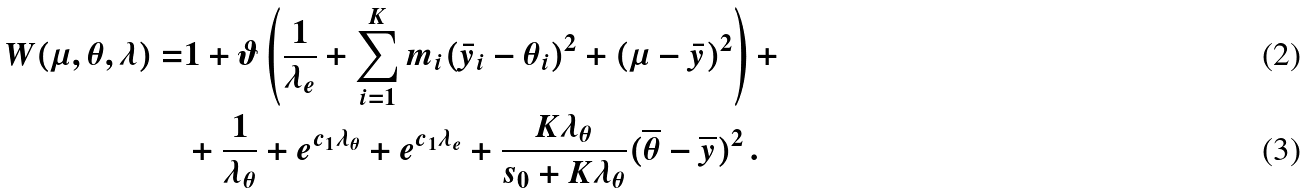<formula> <loc_0><loc_0><loc_500><loc_500>W ( \mu , \theta , \lambda ) = & 1 + \vartheta \left ( \frac { 1 } { \lambda _ { e } } + \sum _ { i = 1 } ^ { K } m _ { i } ( \bar { y } _ { i } - \theta _ { i } ) ^ { 2 } + ( \mu - \bar { y } ) ^ { 2 } \right ) + \\ & + \frac { 1 } { \lambda _ { \theta } } + e ^ { c _ { 1 } \lambda _ { \theta } } + e ^ { c _ { 1 } \lambda _ { e } } + \frac { K \lambda _ { \theta } } { s _ { 0 } + K \lambda _ { \theta } } ( \overline { \theta } - \overline { y } ) ^ { 2 } \, .</formula> 